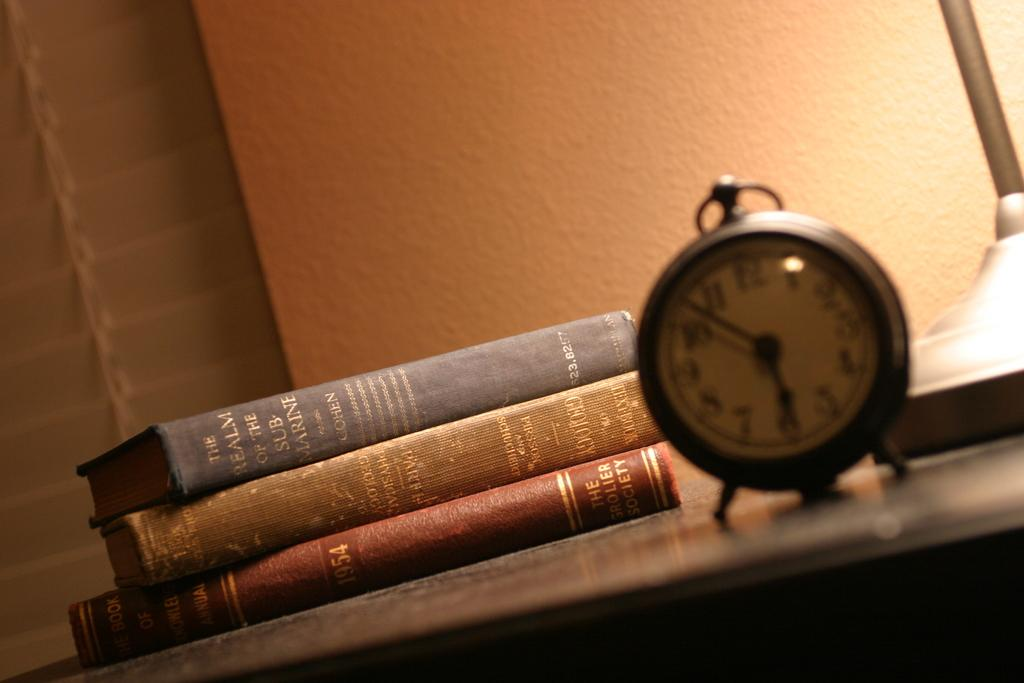<image>
Summarize the visual content of the image. Three books on a desk, one of which being about submarines, along with an out of focus clock in front of them. 